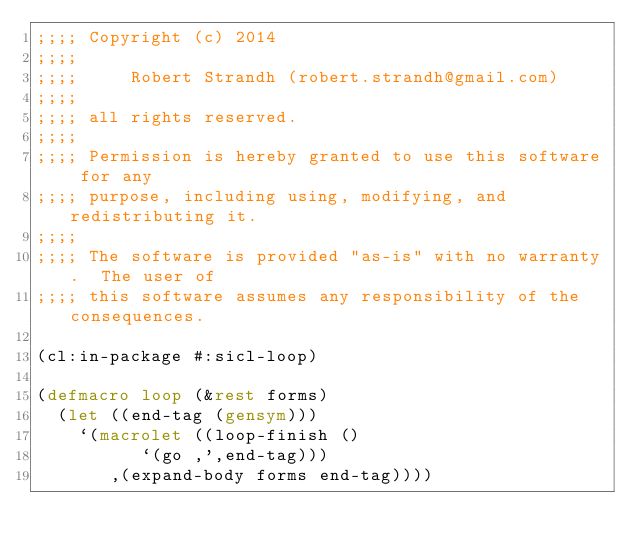Convert code to text. <code><loc_0><loc_0><loc_500><loc_500><_Lisp_>;;;; Copyright (c) 2014
;;;;
;;;;     Robert Strandh (robert.strandh@gmail.com)
;;;;
;;;; all rights reserved. 
;;;;
;;;; Permission is hereby granted to use this software for any 
;;;; purpose, including using, modifying, and redistributing it.
;;;;
;;;; The software is provided "as-is" with no warranty.  The user of
;;;; this software assumes any responsibility of the consequences. 

(cl:in-package #:sicl-loop)

(defmacro loop (&rest forms)
  (let ((end-tag (gensym)))
    `(macrolet ((loop-finish ()
		  `(go ,',end-tag)))
       ,(expand-body forms end-tag))))
</code> 